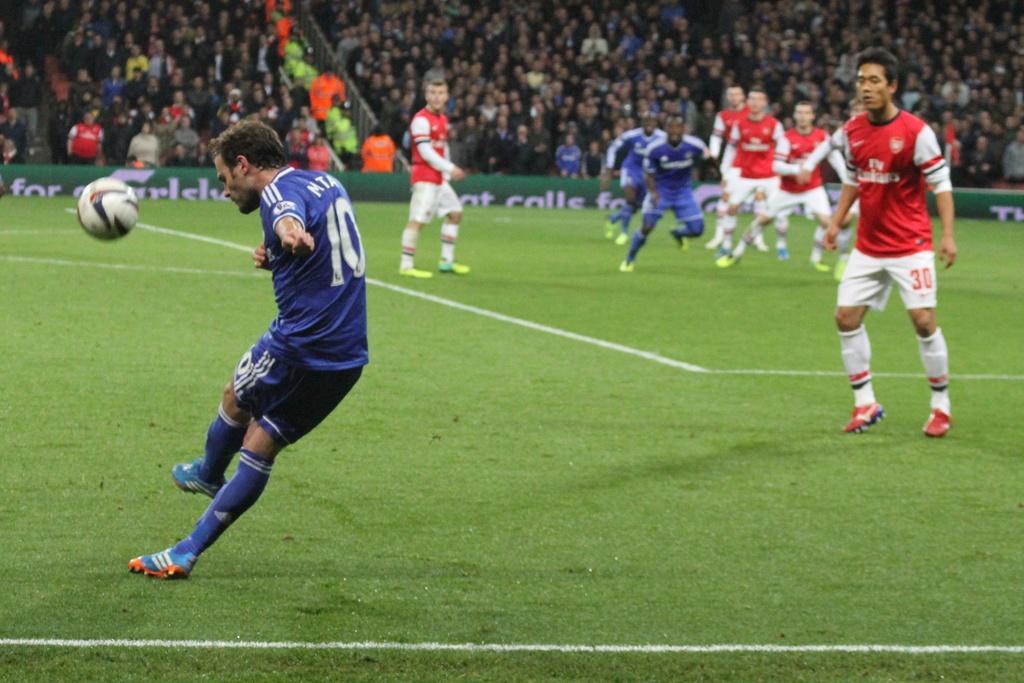Describe this image in one or two sentences. This is a playing ground. At the bottom, I can see the grass. Here I can see few men wearing t-shirts, shorts and playing football. In the background a crowd of people facing towards the ground. 